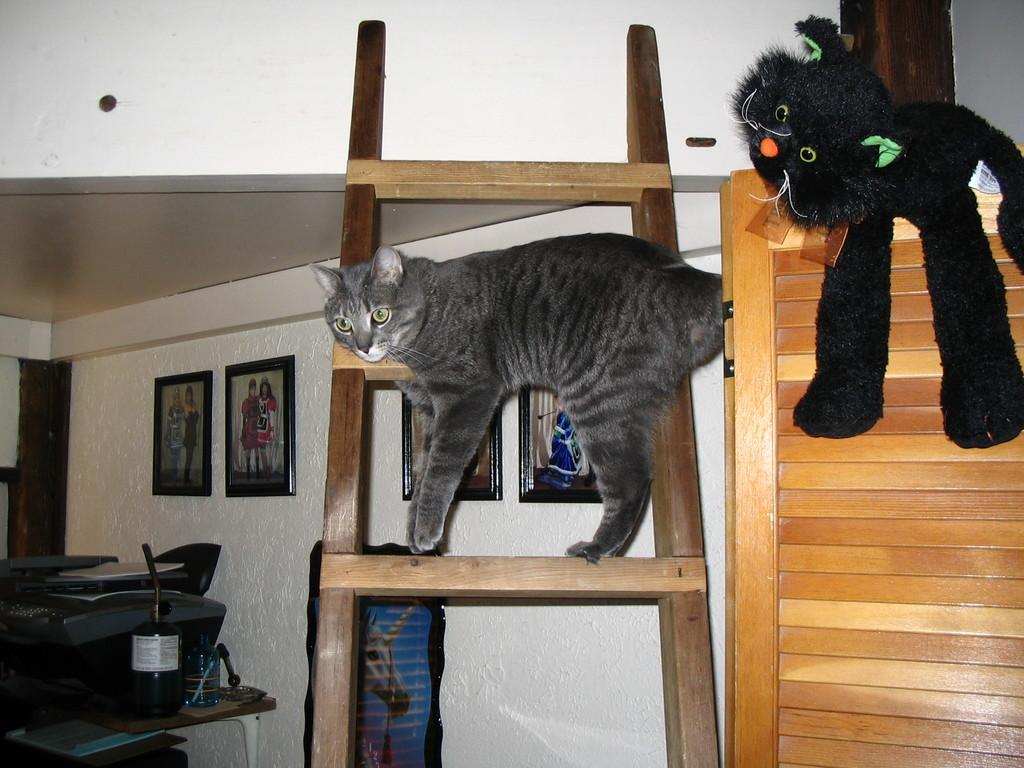What is the cat doing in the image? The cat is on a ladder in the image. What can be seen on the wooden object in the image? There is a toy on a wooden object in the image. What is on the wall in the image? There are photo frames on the wall in the image. What piece of furniture is present in the image? There is a table in the image. What is on the table in the image? There is a bottle on the table in the image. Are there any other objects on the table? Yes, there are other objects on the table in the image. What type of weather can be seen in the image? There is no weather depicted in the image; it is an indoor scene. What kind of pie is being served on the table in the image? There is no pie present in the image. 